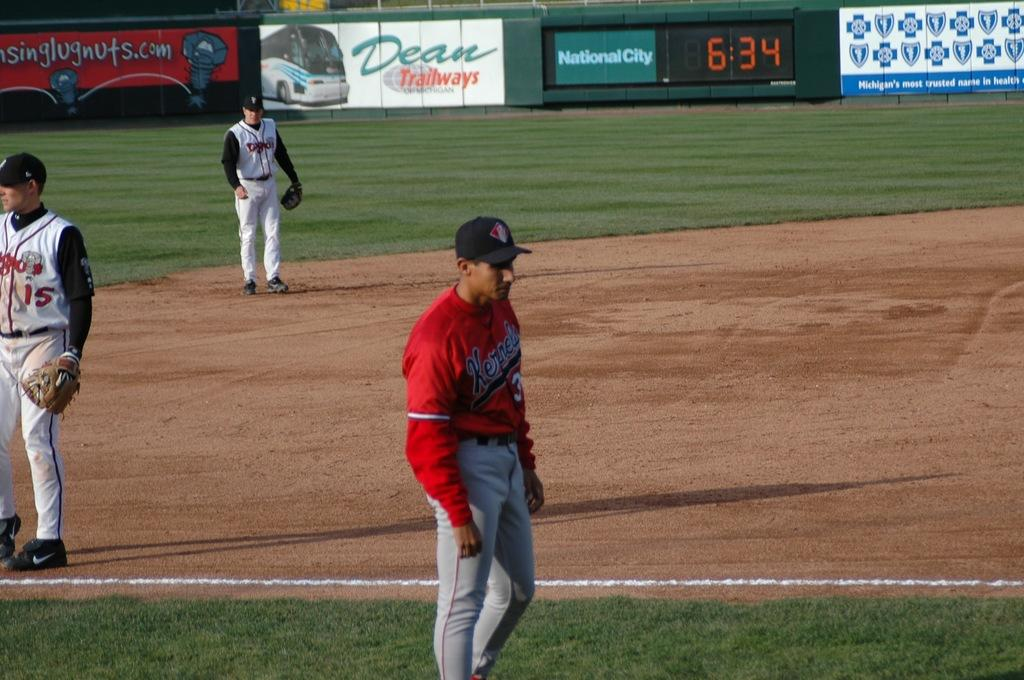Provide a one-sentence caption for the provided image. Baseball players stand around the field waiting for the timer to resume at 6:34. 